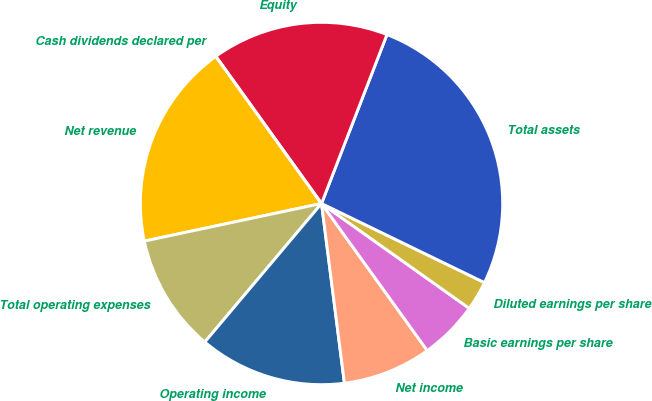<chart> <loc_0><loc_0><loc_500><loc_500><pie_chart><fcel>Net revenue<fcel>Total operating expenses<fcel>Operating income<fcel>Net income<fcel>Basic earnings per share<fcel>Diluted earnings per share<fcel>Total assets<fcel>Equity<fcel>Cash dividends declared per<nl><fcel>18.42%<fcel>10.53%<fcel>13.16%<fcel>7.9%<fcel>5.26%<fcel>2.63%<fcel>26.31%<fcel>15.79%<fcel>0.0%<nl></chart> 